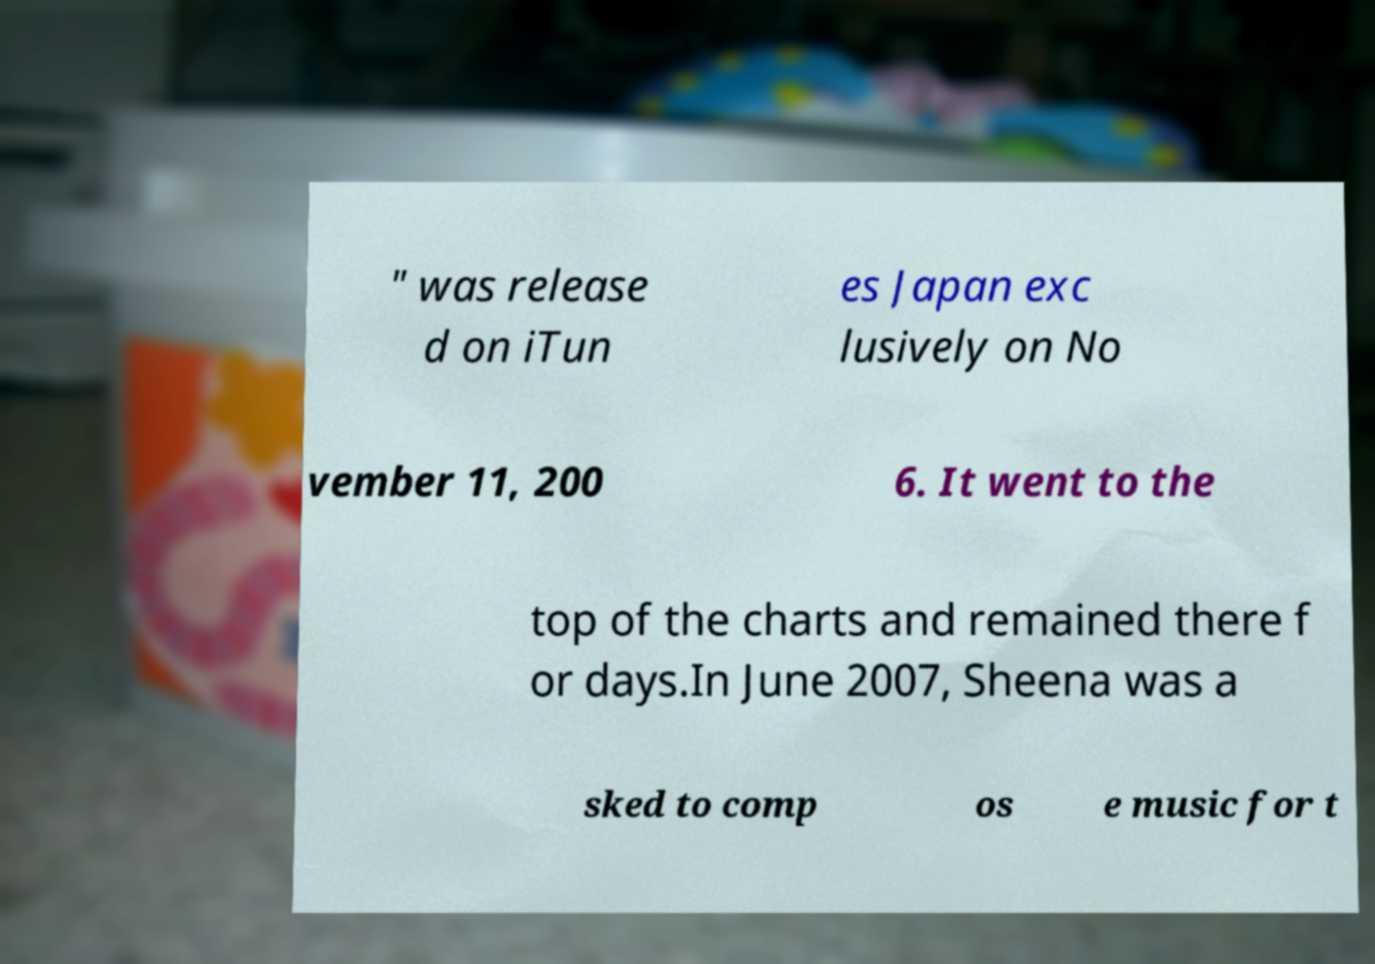Can you read and provide the text displayed in the image?This photo seems to have some interesting text. Can you extract and type it out for me? " was release d on iTun es Japan exc lusively on No vember 11, 200 6. It went to the top of the charts and remained there f or days.In June 2007, Sheena was a sked to comp os e music for t 